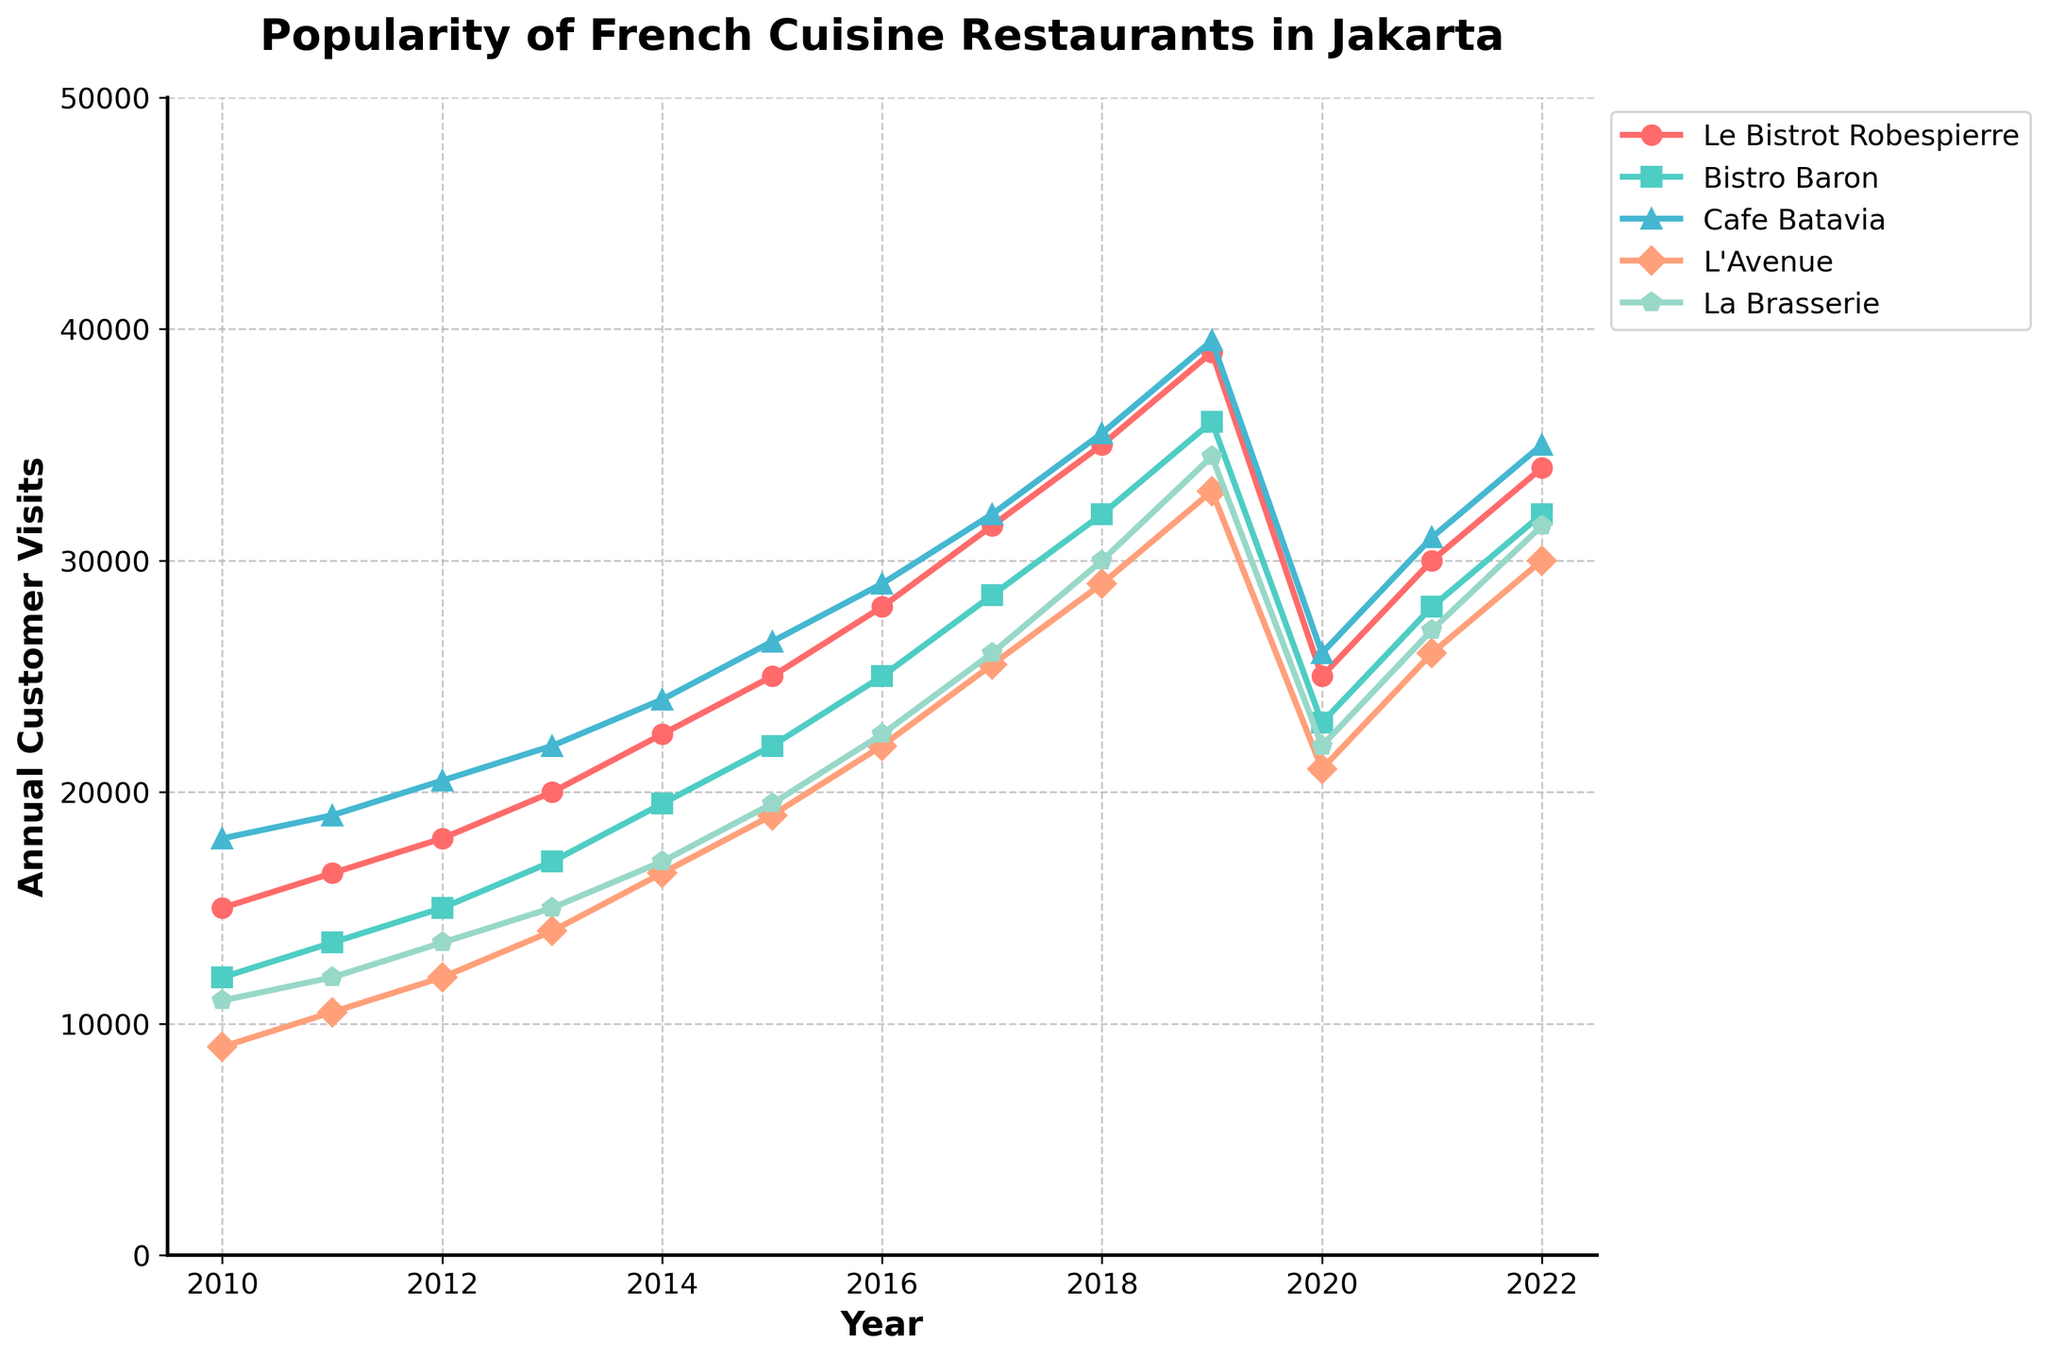What's the trend of customer visits for Le Bistrot Robespierre from 2010 to 2022? Observing the line for Le Bistrot Robespierre, it generally shows an increasing trend from 2010 (15,000 visits) reaching its peak in 2019 (39,000 visits), with a noticeable drop in 2020 (25,000 visits) likely due to external factors before slightly recovering through 2022 (34,000 visits).
Answer: Increasing with a drop in 2020 Which restaurant had the highest annual customer visits in 2019? By comparing the heights of the respective lines in 2019, we can see that Cafe Batavia had the highest number of customer visits (39,500 visits) compared to the other restaurants.
Answer: Cafe Batavia Between Bistro Baron and L'Avenue, which restaurant had a higher increase in customer visits from 2011 to 2014? Bistro Baron increased from 13,500 in 2011 to 19,500 in 2014, an increase of 6,000 visits. L'Avenue increased from 10,500 in 2011 to 16,500 in 2014, an increase of 6,000 visits. Both have the same increase.
Answer: Both are equal What is the average number of customer visits for La Brasserie across the years 2010 to 2022? The values for La Brasserie from 2010 to 2022 are: (11000, 12000, 13500, 15000, 17000, 19500, 22500, 26000, 30000, 34500, 22000, 27000, 31500). Sum these: 11000 + 12000 + 13500 + 15000 + 17000 + 19500 + 22500 + 26000 + 30000 + 34500 + 22000 + 27000 + 31500 = 301000. There are 13 values, so the average is 301000 / 13 ≈ 23154
Answer: 23154 Which restaurant had the sharpest decline in customer visits between 2019 and 2020? By observing the slopes between 2019 and 2020, Le Bistrot Robespierre declined from 39,000 to 25,000 (14,000 decline), Bistro Baron from 36,000 to 23,000 (13,000 decline), Cafe Batavia from 39,500 to 26,000 (13,500 decline), L'Avenue from 33,000 to 21,000 (12,000 decline), and La Brasserie from 34,500 to 22,000 (12,500 decline). Hence, the sharpest decline is seen in Le Bistrot Robespierre.
Answer: Le Bistrot Robespierre In which years did all five restaurants see an increase in customer visits compared to the previous year? Checking year-over-year changes: From 2010-2011, all increase. From 2011-2012, all increase. From 2012-2013, all increase. From 2013-2014, all increase. From 2014-2015, all increase. From 2015-2016, all increase. From 2016-2017, all increase. From 2017-2018, all increase. From 2018-2019, all increase. All restaurants saw collective increases (prior the decrease in 2020) through each year from 2010 to 2019.
Answer: 2010-2019 By how much did customer visits at L'Avenue increase from 2013 to 2017? L'Avenue had 14,000 visits in 2013 and 25,500 visits in 2017. The increase is calculated as 25,500 - 14,000 = 11,500 visits.
Answer: 11,500 visits 